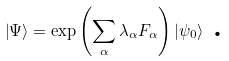Convert formula to latex. <formula><loc_0><loc_0><loc_500><loc_500>\left | \Psi \right \rangle = \exp \left ( \sum _ { \alpha } \lambda _ { \alpha } F _ { \alpha } \right ) \left | \psi _ { 0 } \right \rangle \text { .}</formula> 